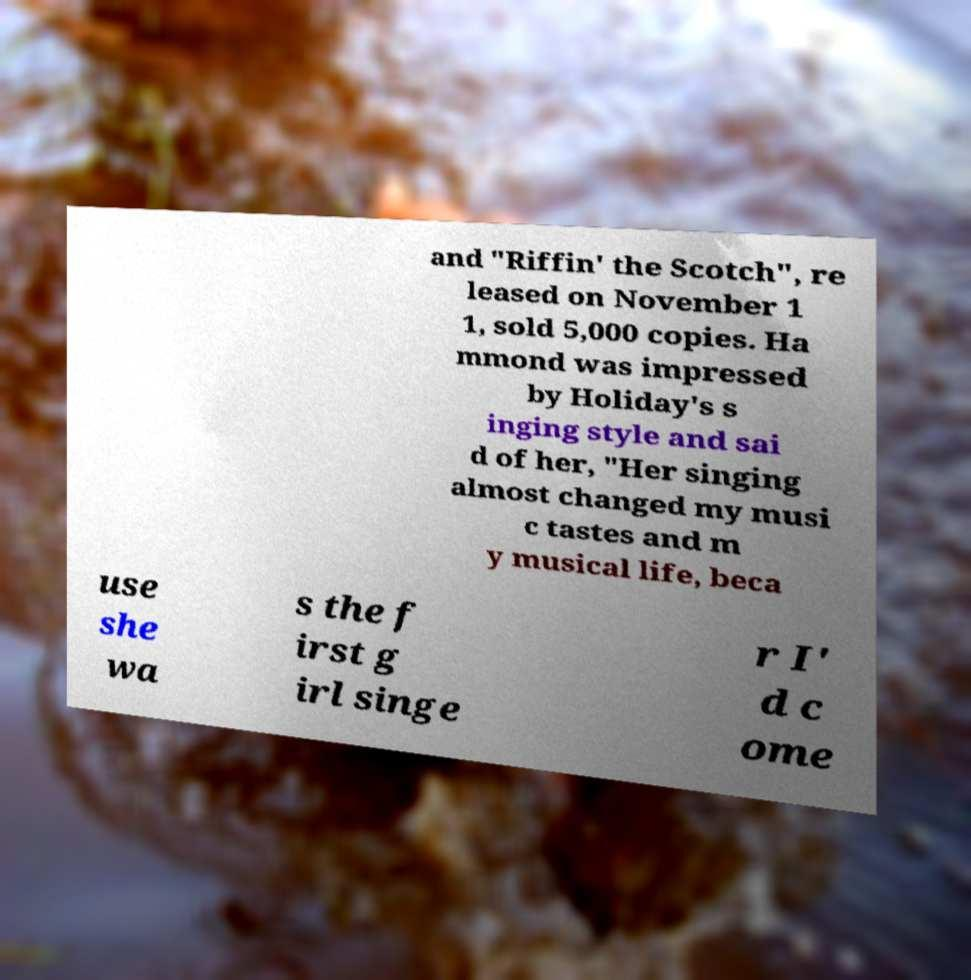Please read and relay the text visible in this image. What does it say? and "Riffin' the Scotch", re leased on November 1 1, sold 5,000 copies. Ha mmond was impressed by Holiday's s inging style and sai d of her, "Her singing almost changed my musi c tastes and m y musical life, beca use she wa s the f irst g irl singe r I' d c ome 